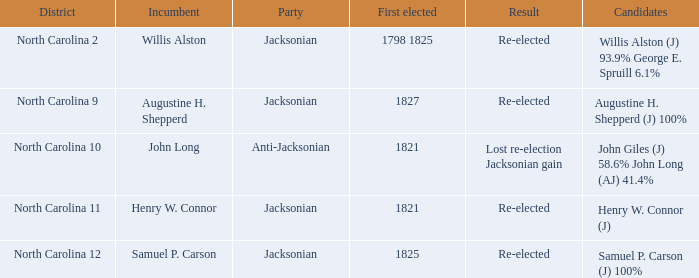State the entire quantity of events for willis alston. 1.0. 